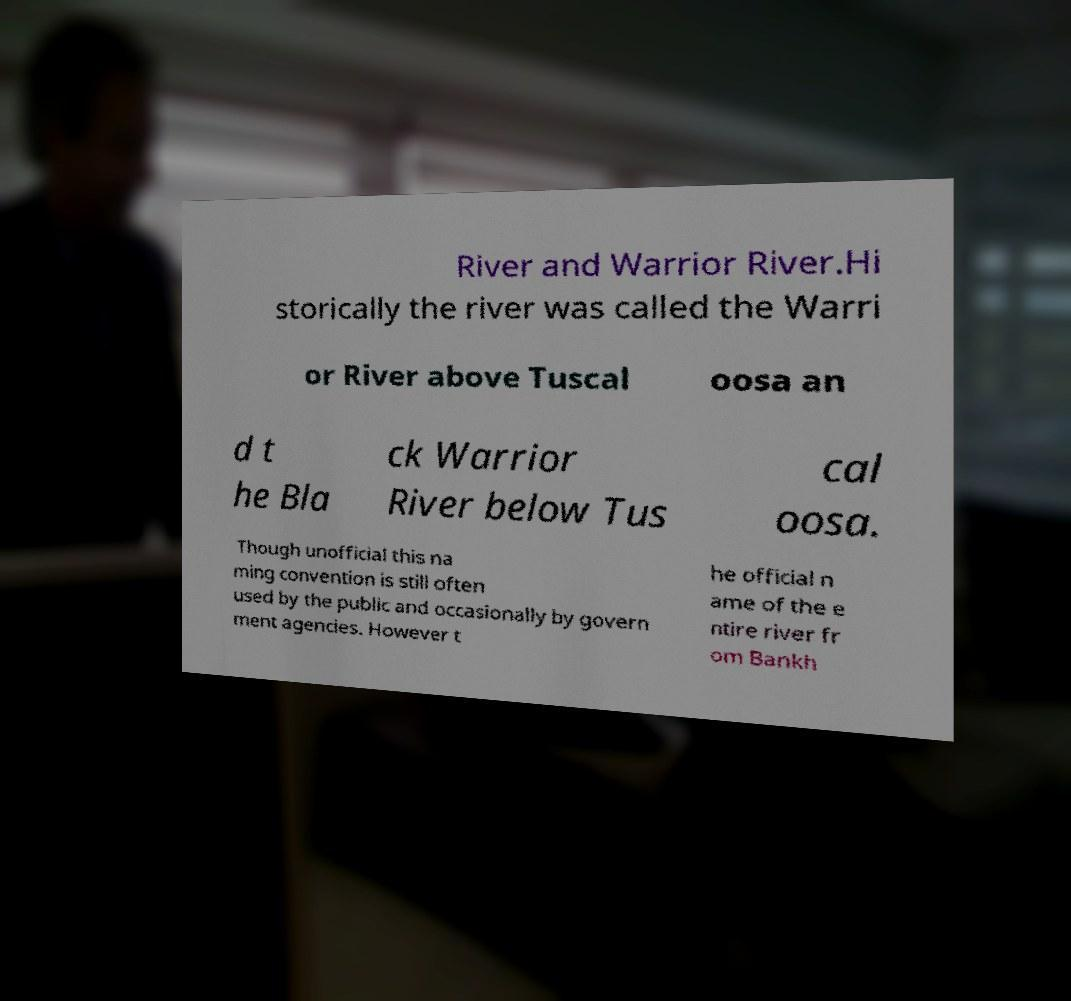Please read and relay the text visible in this image. What does it say? River and Warrior River.Hi storically the river was called the Warri or River above Tuscal oosa an d t he Bla ck Warrior River below Tus cal oosa. Though unofficial this na ming convention is still often used by the public and occasionally by govern ment agencies. However t he official n ame of the e ntire river fr om Bankh 